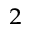<formula> <loc_0><loc_0><loc_500><loc_500>^ { 2 }</formula> 